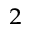<formula> <loc_0><loc_0><loc_500><loc_500>^ { 2 }</formula> 